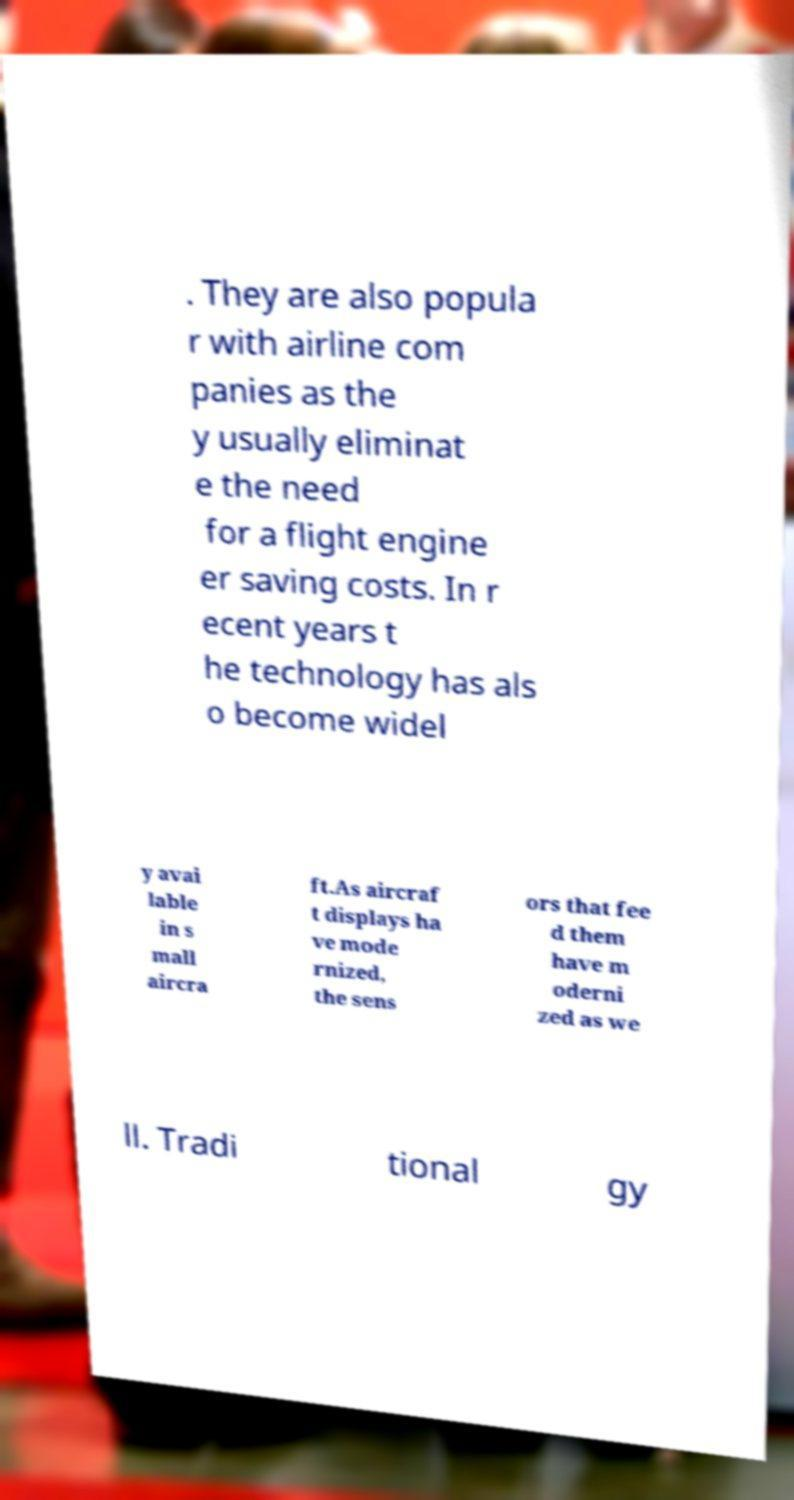I need the written content from this picture converted into text. Can you do that? . They are also popula r with airline com panies as the y usually eliminat e the need for a flight engine er saving costs. In r ecent years t he technology has als o become widel y avai lable in s mall aircra ft.As aircraf t displays ha ve mode rnized, the sens ors that fee d them have m oderni zed as we ll. Tradi tional gy 